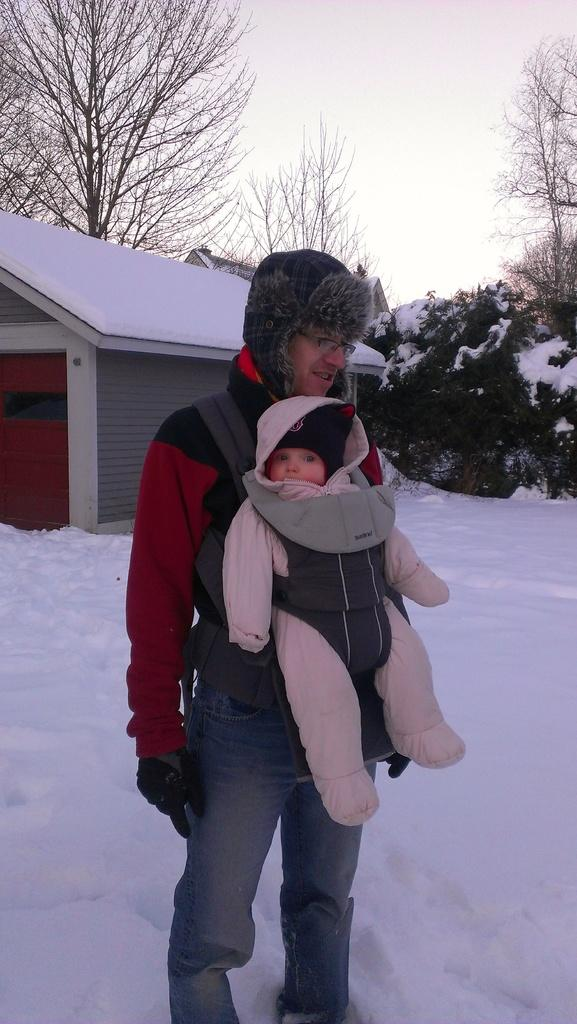What is the person in the image doing? The person is standing on the road and holding a baby. What can be seen in the background of the image? There is a house, trees, and the sky visible in the background. When was the image taken? The image was taken during the day. How many ducks are swimming in the basin in the image? There are no ducks or basin present in the image. 